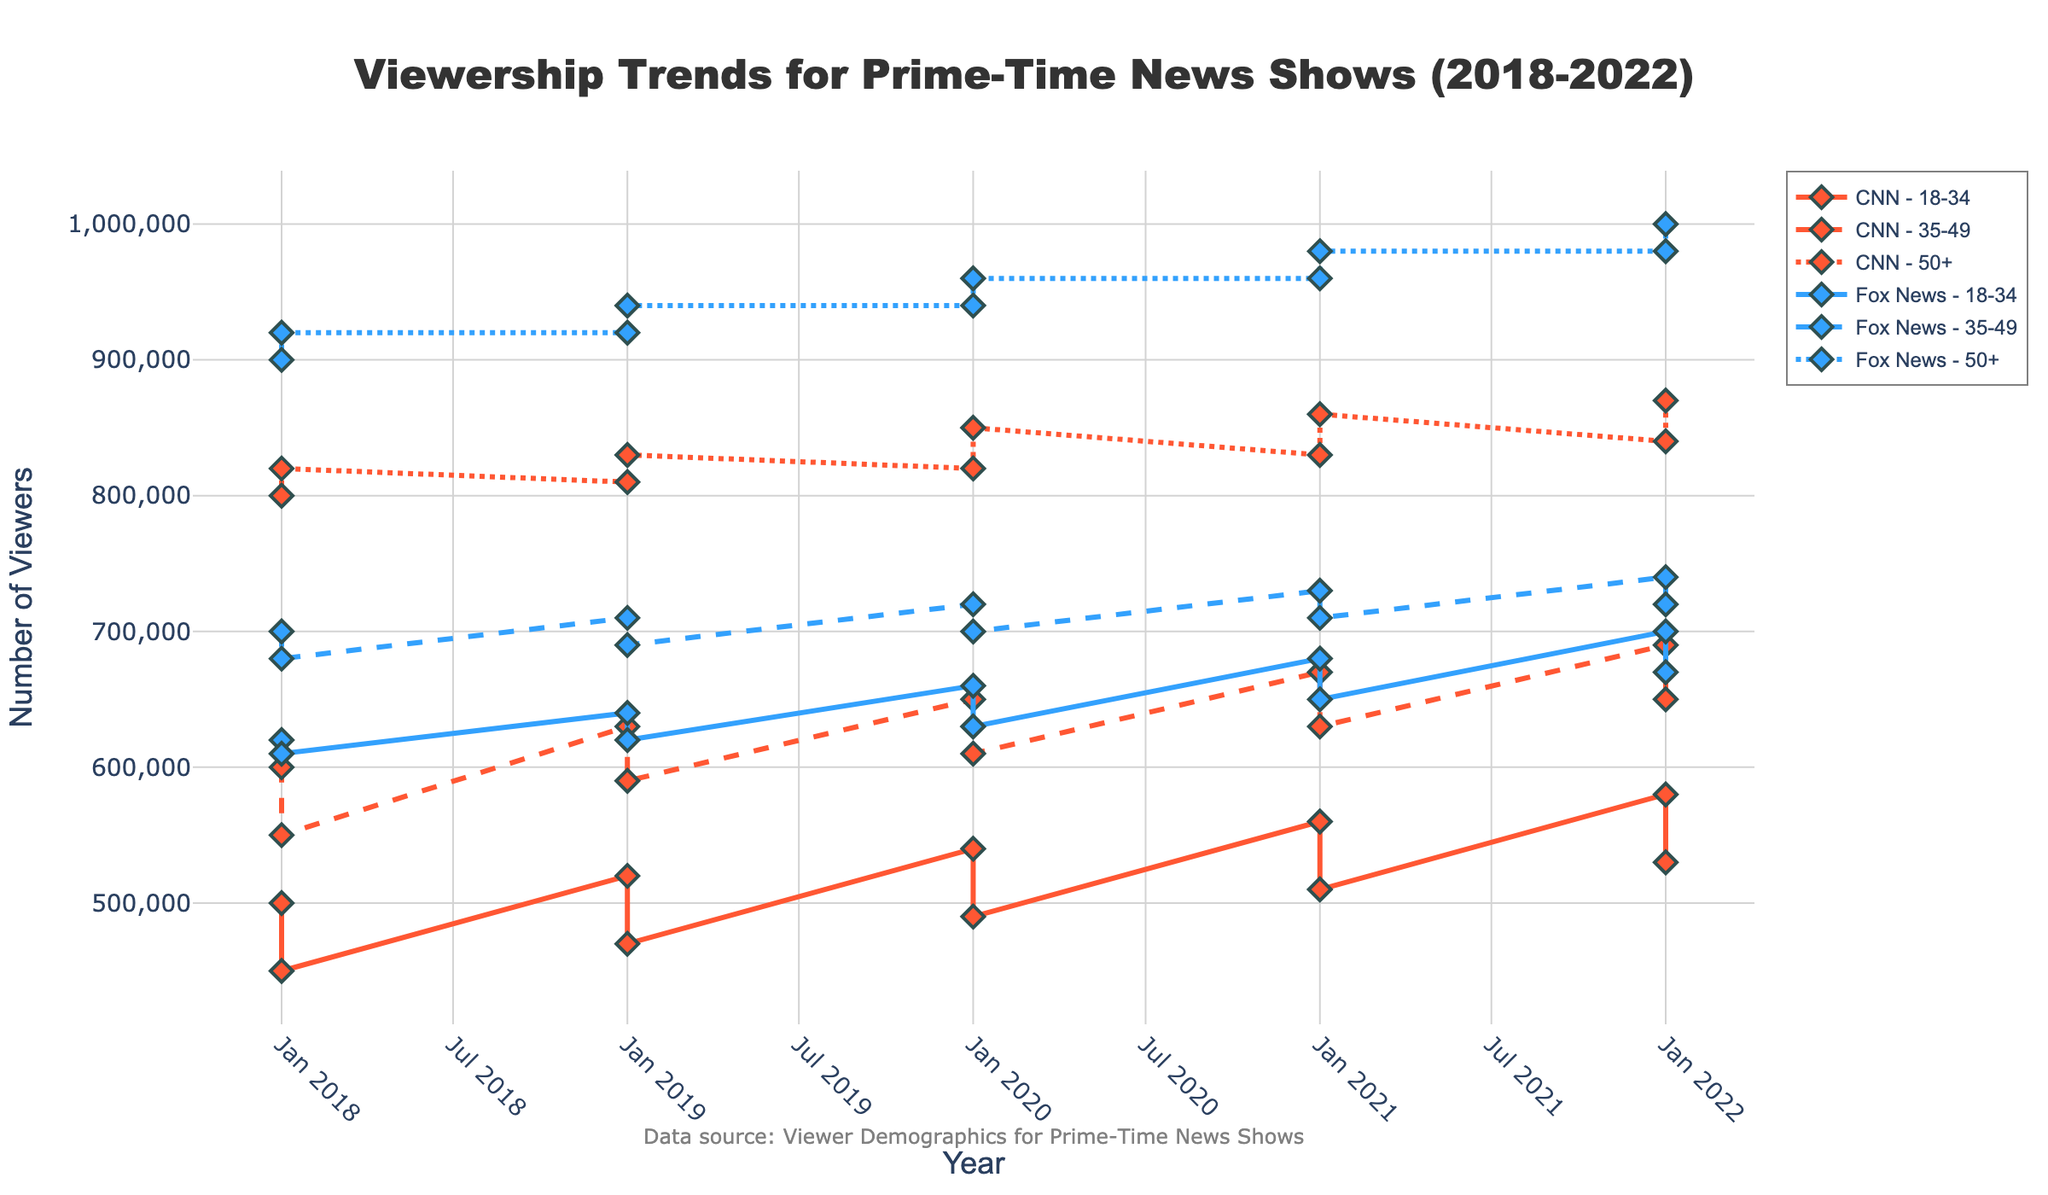What's the title of the figure? The title of the figure is usually displayed at the top. For this plot, the title should be explicitly mentioned.
Answer: Viewership Trends for Prime-Time News Shows (2018-2022) How is the viewership for CNN and Fox News differentiated visually? Viewership for CNN and Fox News is differentiated by color; CNN is shown in one color and Fox News in another as indicated in the code with specific color codes associated with each channel.
Answer: By different colors Which age group had the highest viewership in 2022 for Fox News? Looking at the plot's lines and markers for Fox News in the year 2022, we can identify the age group with the highest viewership. The highest peak marker for Fox News in 2022 corresponds to the age group 50+.
Answer: Age group 50+ How did the viewership for the 18-34 age group for CNN change from 2018 to 2022? Trace the line plot for the 18-34 age group for CNN from 2018 to 2022, noting the incremental or decremental changes in viewership values over these years. It shows a consistent increase every year.
Answer: Increased What is the viewership difference between male and female viewers aged 50+ for CNN in 2020? Identify the viewership numbers for male and female viewers aged 50+ for CNN in 2020 and calculate the absolute difference. Male viewership is 820,000 and female viewership is 850,000. The difference is 850,000 - 820,000.
Answer: 30,000 On average, what was the viewership for Fox News across all age groups in 2019? Calculate the viewership average for Fox News in 2019 by summing all viewership values for different age groups and dividing by the number of groups (6 age/gender groups). (640,000 + 620,000 + 710,000 + 690,000 + 920,000 + 940,000) / 6 = 753,333.33
Answer: 753,333.33 Which year had the lowest viewership for females aged 35-49 watching CNN? Inspect the trend for female viewers aged 35-49 watching CNN, identifying the year with the lowest marker value. Cross-reference yearly values to identify the lowest.
Answer: 2018 Does the viewership trend for Fox News show an overall increasing or decreasing trend from 2018 to 2022 for the age group 35-49? Observe the trend line specific to the age group 35-49 under Fox News from 2018 to 2022. Note the starting and ending points to determine if the trend line slopes upward (increasing) or downward (decreasing).
Answer: Increasing What is the combined viewership for all male viewers in 2021 across both CNN and Fox News? Sum the viewership numbers for all male viewers (across all age groups) for both CNN and Fox News in the year 2021. (560,000 + 670,000 + 830,000 for CNN) + (680,000 + 730,000 + 960,000 for Fox News) = 3,430,000
Answer: 3,430,000 